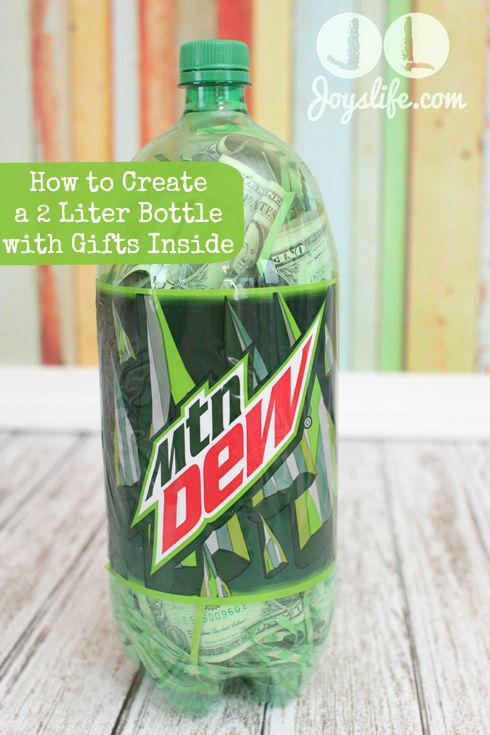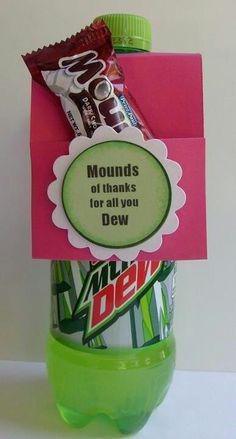The first image is the image on the left, the second image is the image on the right. Given the left and right images, does the statement "Each image contains at least one green soda bottle, and the left image features a bottle with a label that includes jagged shapes and red letters." hold true? Answer yes or no. Yes. The first image is the image on the left, the second image is the image on the right. Assess this claim about the two images: "One of the bottles contains money bills.". Correct or not? Answer yes or no. Yes. 